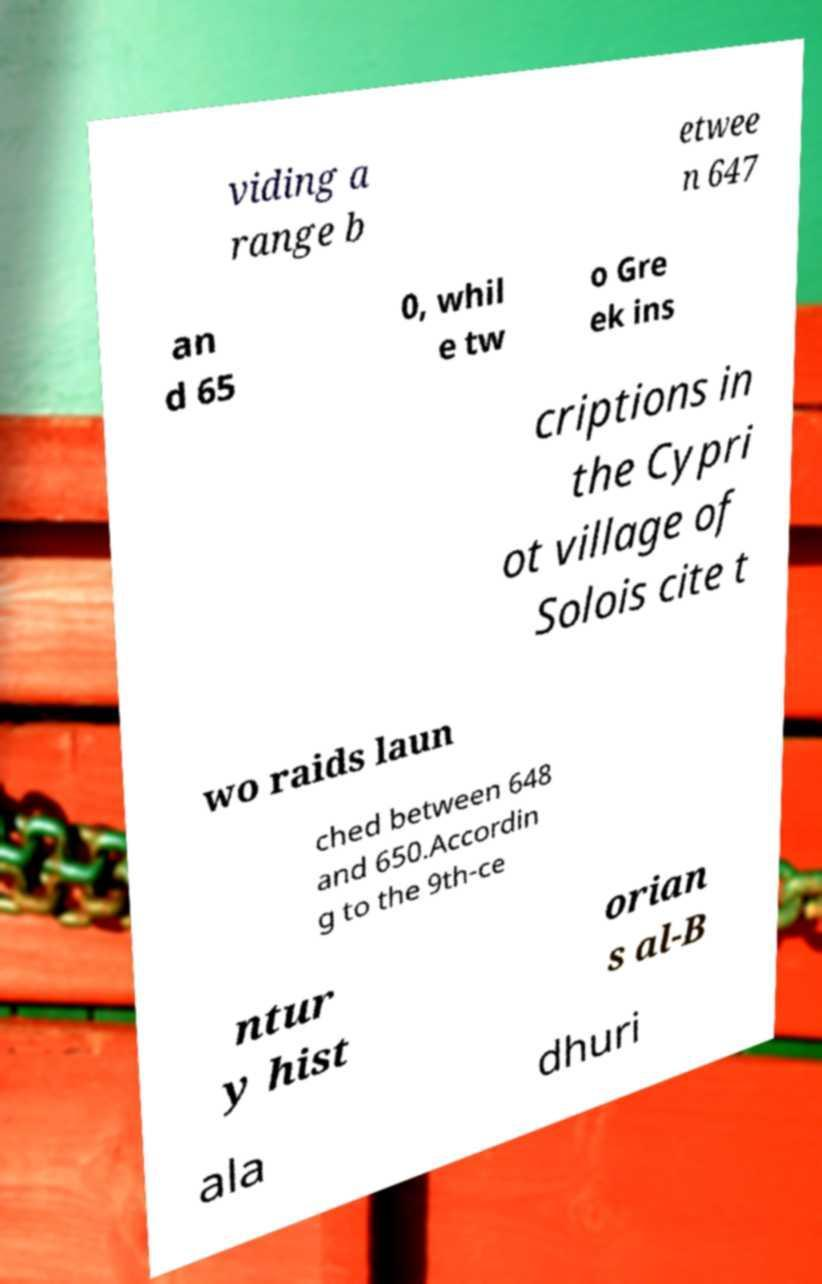Can you read and provide the text displayed in the image?This photo seems to have some interesting text. Can you extract and type it out for me? viding a range b etwee n 647 an d 65 0, whil e tw o Gre ek ins criptions in the Cypri ot village of Solois cite t wo raids laun ched between 648 and 650.Accordin g to the 9th-ce ntur y hist orian s al-B ala dhuri 